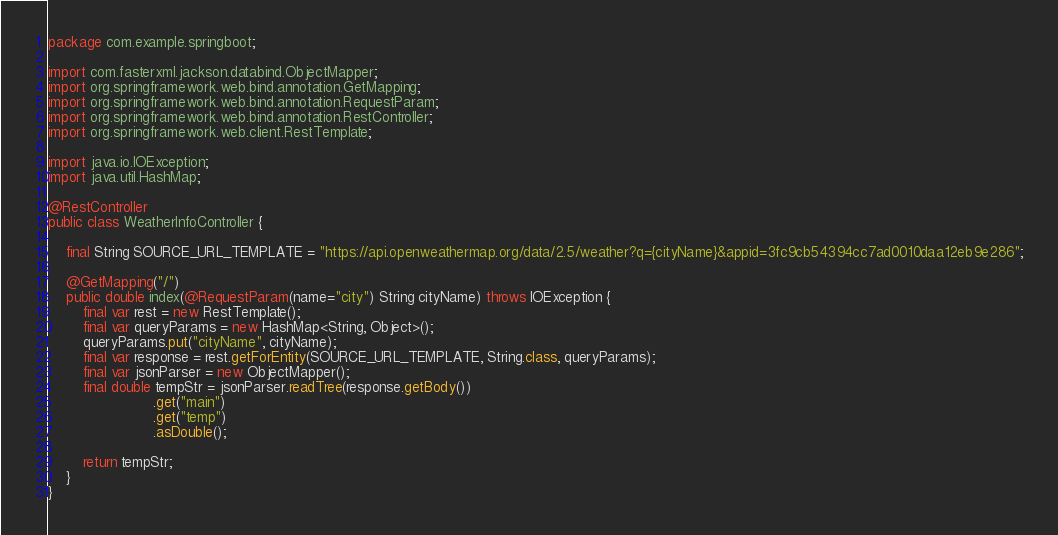<code> <loc_0><loc_0><loc_500><loc_500><_Java_>package com.example.springboot;

import com.fasterxml.jackson.databind.ObjectMapper;
import org.springframework.web.bind.annotation.GetMapping;
import org.springframework.web.bind.annotation.RequestParam;
import org.springframework.web.bind.annotation.RestController;
import org.springframework.web.client.RestTemplate;

import java.io.IOException;
import java.util.HashMap;

@RestController
public class WeatherInfoController {

	final String SOURCE_URL_TEMPLATE = "https://api.openweathermap.org/data/2.5/weather?q={cityName}&appid=3fc9cb54394cc7ad0010daa12eb9e286";

	@GetMapping("/")
	public double index(@RequestParam(name="city") String cityName) throws IOException {
		final var rest = new RestTemplate();
		final var queryParams = new HashMap<String, Object>();
		queryParams.put("cityName", cityName);
		final var response = rest.getForEntity(SOURCE_URL_TEMPLATE, String.class, queryParams);
		final var jsonParser = new ObjectMapper();
		final double tempStr = jsonParser.readTree(response.getBody())
						.get("main")
						.get("temp")
						.asDouble();

		return tempStr;
	}
}
</code> 